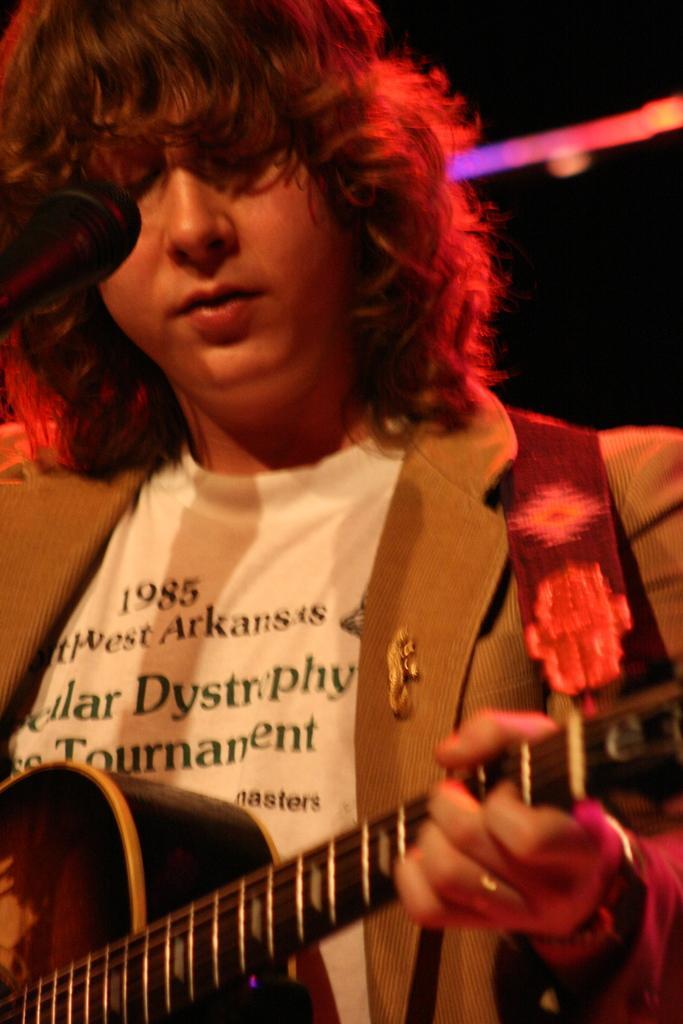Please provide a concise description of this image. In the foreground of the picture there is a person playing guitar. On the left there is a microphone. In the background there are lights. 